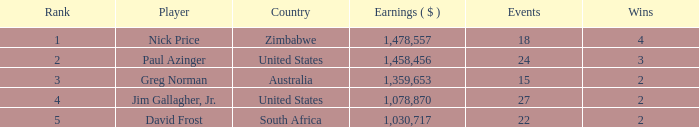How many occurrences have earnings below 1,030,717? 0.0. 